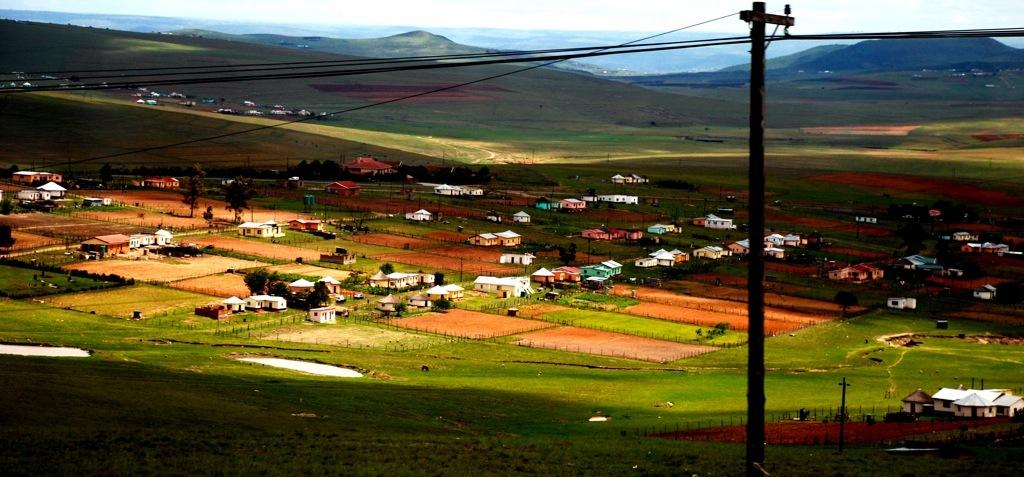What structures can be seen in the image? There are poles and wires in the image. What type of terrain is visible in the image? There is an open grass ground in the image. What else can be seen in the image besides the poles and wires? There are buildings in the image. What is visible in the background of the image? There are mountains visible in the background of the image. What type of soup is being served in the image? There is no soup present in the image. What activity are the police officers performing in the image? There are no police officers present in the image. 